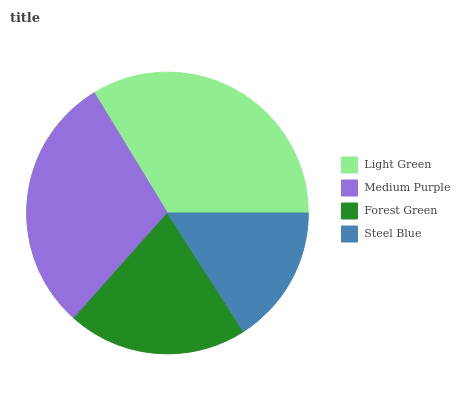Is Steel Blue the minimum?
Answer yes or no. Yes. Is Light Green the maximum?
Answer yes or no. Yes. Is Medium Purple the minimum?
Answer yes or no. No. Is Medium Purple the maximum?
Answer yes or no. No. Is Light Green greater than Medium Purple?
Answer yes or no. Yes. Is Medium Purple less than Light Green?
Answer yes or no. Yes. Is Medium Purple greater than Light Green?
Answer yes or no. No. Is Light Green less than Medium Purple?
Answer yes or no. No. Is Medium Purple the high median?
Answer yes or no. Yes. Is Forest Green the low median?
Answer yes or no. Yes. Is Forest Green the high median?
Answer yes or no. No. Is Medium Purple the low median?
Answer yes or no. No. 